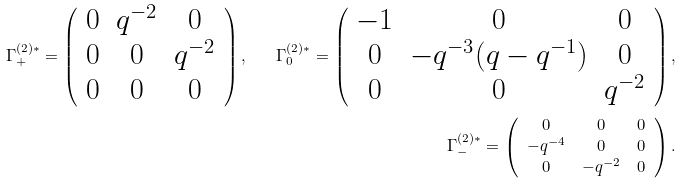<formula> <loc_0><loc_0><loc_500><loc_500>\Gamma _ { + } ^ { ( 2 ) * } = \left ( \begin{array} { c c c } 0 & q ^ { - 2 } & 0 \\ 0 & 0 & q ^ { - 2 } \\ 0 & 0 & 0 \end{array} \right ) , \quad \Gamma _ { 0 } ^ { ( 2 ) * } = \left ( \begin{array} { c c c } - 1 & 0 & 0 \\ 0 & - q ^ { - 3 } ( q - q ^ { - 1 } ) & 0 \\ 0 & 0 & q ^ { - 2 } \end{array} \right ) , \\ \Gamma _ { - } ^ { ( 2 ) * } = \left ( \begin{array} { c c c } 0 & 0 & 0 \\ - q ^ { - 4 } & 0 & 0 \\ 0 & - q ^ { - 2 } & 0 \end{array} \right ) .</formula> 